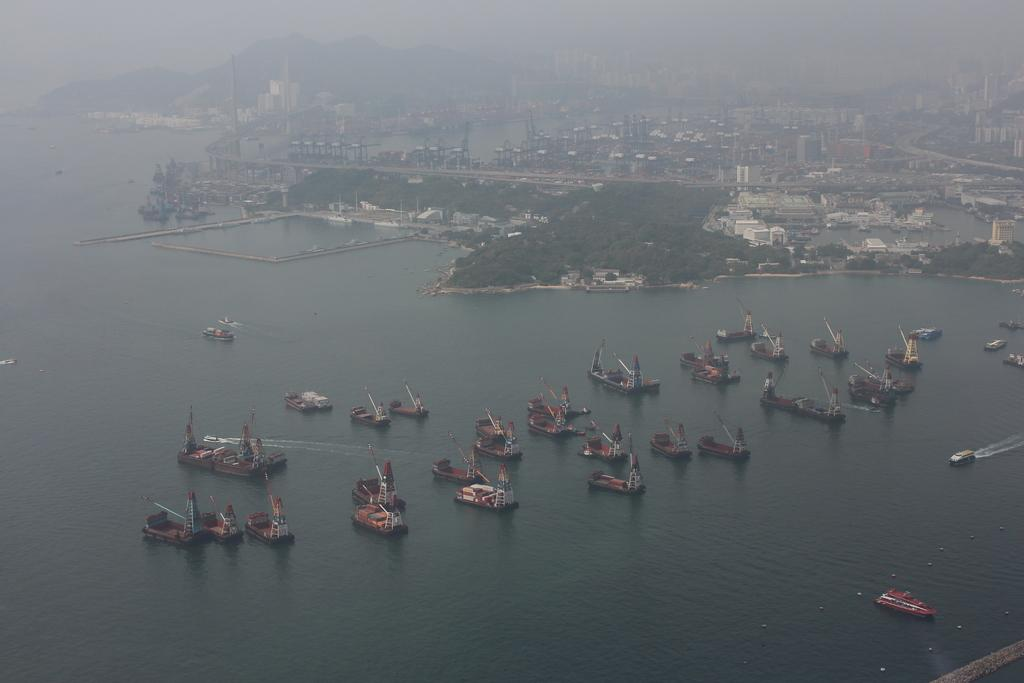What can be seen floating on the water in the image? There are boats on the water in the image. What type of natural elements can be seen in the background? There are trees, mountains, and the sky visible in the background. What type of man-made structures can be seen in the background? There are buildings, poles, and a road visible in the background. What other objects can be seen in the background? There are other objects in the background, but their specific details are not mentioned in the provided facts. What flavor of chess can be seen on the table in the image? There is no chess or table present in the image. How many fingers are visible in the image? There is no reference to fingers or any body parts in the image. 